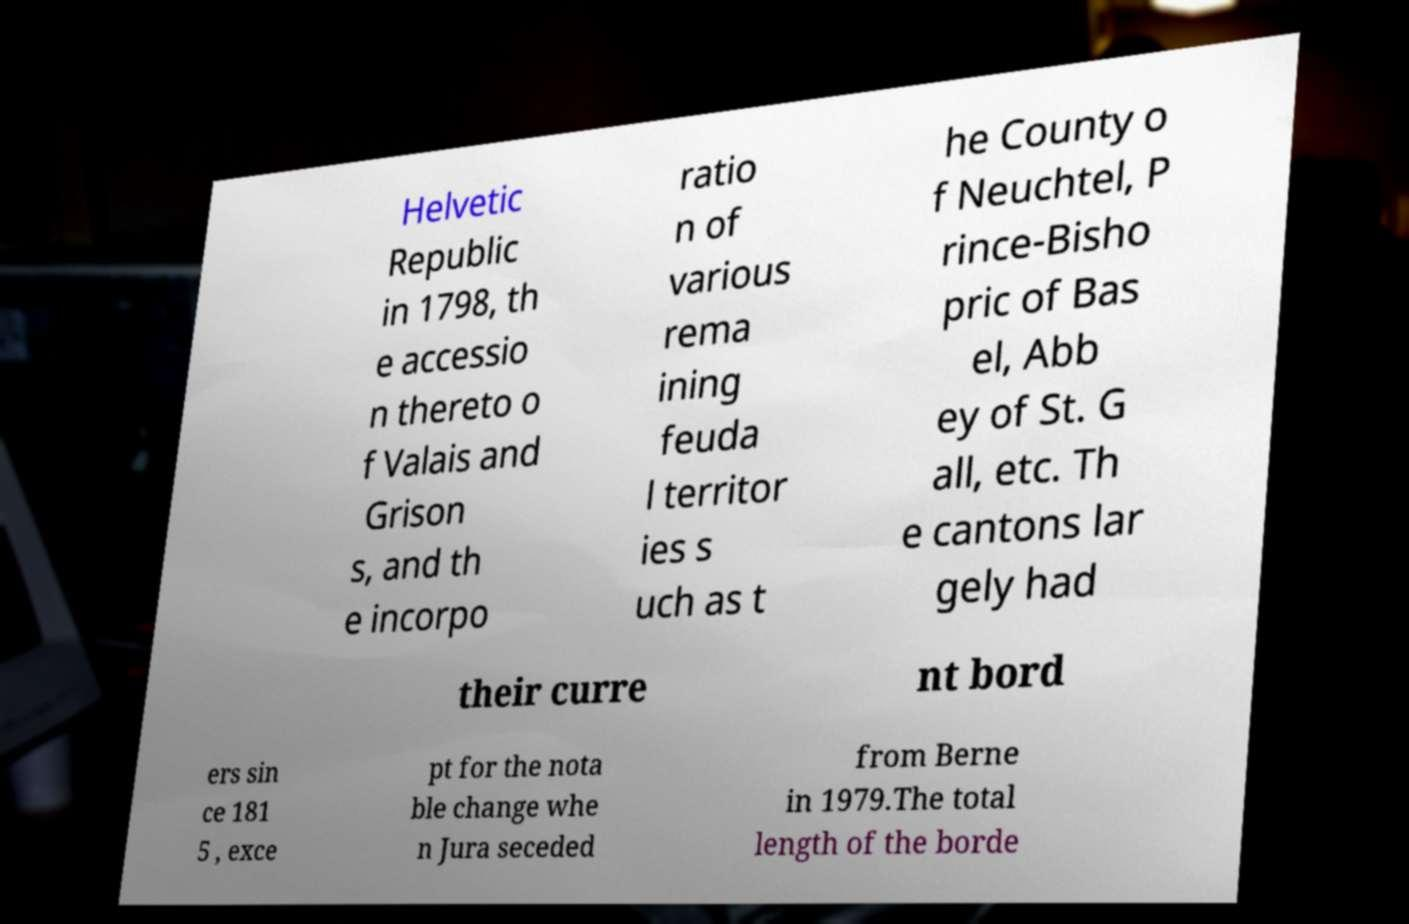What messages or text are displayed in this image? I need them in a readable, typed format. Helvetic Republic in 1798, th e accessio n thereto o f Valais and Grison s, and th e incorpo ratio n of various rema ining feuda l territor ies s uch as t he County o f Neuchtel, P rince-Bisho pric of Bas el, Abb ey of St. G all, etc. Th e cantons lar gely had their curre nt bord ers sin ce 181 5 , exce pt for the nota ble change whe n Jura seceded from Berne in 1979.The total length of the borde 